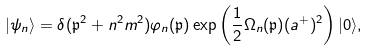<formula> <loc_0><loc_0><loc_500><loc_500>| \psi _ { n } \rangle = \delta ( \mathfrak p ^ { 2 } + n ^ { 2 } m ^ { 2 } ) \varphi _ { n } ( \mathfrak p ) \exp \left ( \frac { 1 } { 2 } \Omega _ { n } ( \mathfrak p ) ( a ^ { + } ) ^ { 2 } \right ) | 0 \rangle ,</formula> 